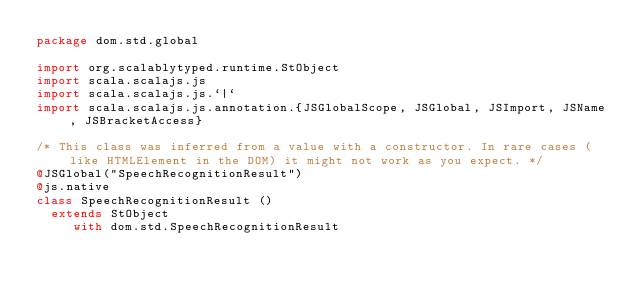Convert code to text. <code><loc_0><loc_0><loc_500><loc_500><_Scala_>package dom.std.global

import org.scalablytyped.runtime.StObject
import scala.scalajs.js
import scala.scalajs.js.`|`
import scala.scalajs.js.annotation.{JSGlobalScope, JSGlobal, JSImport, JSName, JSBracketAccess}

/* This class was inferred from a value with a constructor. In rare cases (like HTMLElement in the DOM) it might not work as you expect. */
@JSGlobal("SpeechRecognitionResult")
@js.native
class SpeechRecognitionResult ()
  extends StObject
     with dom.std.SpeechRecognitionResult
</code> 